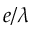<formula> <loc_0><loc_0><loc_500><loc_500>e / \lambda</formula> 